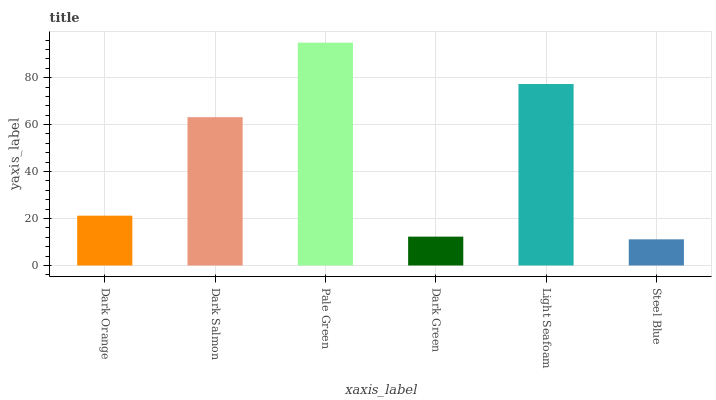Is Steel Blue the minimum?
Answer yes or no. Yes. Is Pale Green the maximum?
Answer yes or no. Yes. Is Dark Salmon the minimum?
Answer yes or no. No. Is Dark Salmon the maximum?
Answer yes or no. No. Is Dark Salmon greater than Dark Orange?
Answer yes or no. Yes. Is Dark Orange less than Dark Salmon?
Answer yes or no. Yes. Is Dark Orange greater than Dark Salmon?
Answer yes or no. No. Is Dark Salmon less than Dark Orange?
Answer yes or no. No. Is Dark Salmon the high median?
Answer yes or no. Yes. Is Dark Orange the low median?
Answer yes or no. Yes. Is Dark Orange the high median?
Answer yes or no. No. Is Pale Green the low median?
Answer yes or no. No. 